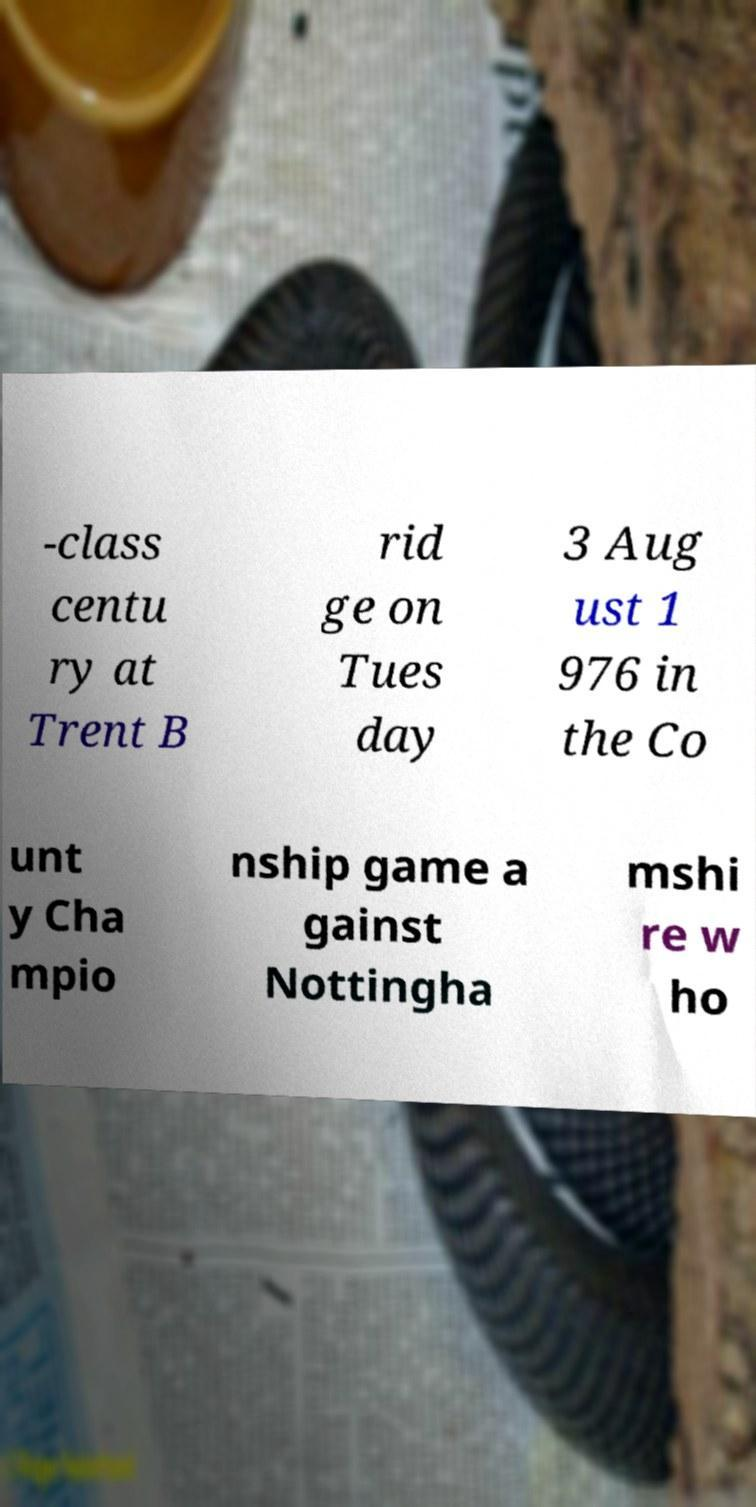Could you assist in decoding the text presented in this image and type it out clearly? -class centu ry at Trent B rid ge on Tues day 3 Aug ust 1 976 in the Co unt y Cha mpio nship game a gainst Nottingha mshi re w ho 